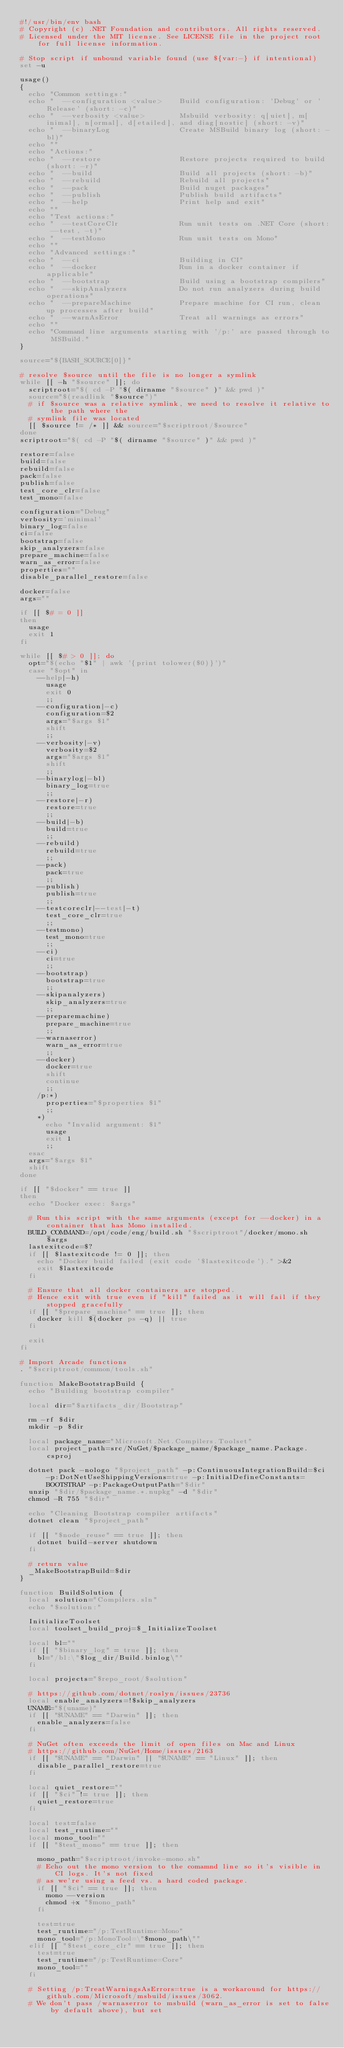Convert code to text. <code><loc_0><loc_0><loc_500><loc_500><_Bash_>#!/usr/bin/env bash
# Copyright (c) .NET Foundation and contributors. All rights reserved.
# Licensed under the MIT license. See LICENSE file in the project root for full license information.

# Stop script if unbound variable found (use ${var:-} if intentional)
set -u

usage()
{
  echo "Common settings:"
  echo "  --configuration <value>    Build configuration: 'Debug' or 'Release' (short: -c)"
  echo "  --verbosity <value>        Msbuild verbosity: q[uiet], m[inimal], n[ormal], d[etailed], and diag[nostic] (short: -v)"
  echo "  --binaryLog                Create MSBuild binary log (short: -bl)"
  echo ""
  echo "Actions:"
  echo "  --restore                  Restore projects required to build (short: -r)"
  echo "  --build                    Build all projects (short: -b)"
  echo "  --rebuild                  Rebuild all projects"
  echo "  --pack                     Build nuget packages"
  echo "  --publish                  Publish build artifacts"
  echo "  --help                     Print help and exit"
  echo ""
  echo "Test actions:"     
  echo "  --testCoreClr              Run unit tests on .NET Core (short: --test, -t)"
  echo "  --testMono                 Run unit tests on Mono"
  echo ""
  echo "Advanced settings:"
  echo "  --ci                       Building in CI"
  echo "  --docker                   Run in a docker container if applicable"
  echo "  --bootstrap                Build using a bootstrap compilers"
  echo "  --skipAnalyzers            Do not run analyzers during build operations"
  echo "  --prepareMachine           Prepare machine for CI run, clean up processes after build"
  echo "  --warnAsError              Treat all warnings as errors"
  echo ""
  echo "Command line arguments starting with '/p:' are passed through to MSBuild."
}

source="${BASH_SOURCE[0]}"

# resolve $source until the file is no longer a symlink
while [[ -h "$source" ]]; do
  scriptroot="$( cd -P "$( dirname "$source" )" && pwd )"
  source="$(readlink "$source")"
  # if $source was a relative symlink, we need to resolve it relative to the path where the
  # symlink file was located
  [[ $source != /* ]] && source="$scriptroot/$source"
done
scriptroot="$( cd -P "$( dirname "$source" )" && pwd )"

restore=false
build=false
rebuild=false
pack=false
publish=false
test_core_clr=false
test_mono=false

configuration="Debug"
verbosity='minimal'
binary_log=false
ci=false
bootstrap=false
skip_analyzers=false
prepare_machine=false
warn_as_error=false
properties=""
disable_parallel_restore=false

docker=false
args=""

if [[ $# = 0 ]]
then
  usage
  exit 1
fi

while [[ $# > 0 ]]; do
  opt="$(echo "$1" | awk '{print tolower($0)}')"
  case "$opt" in
    --help|-h)
      usage
      exit 0
      ;;
    --configuration|-c)
      configuration=$2
      args="$args $1"
      shift
      ;;
    --verbosity|-v)
      verbosity=$2
      args="$args $1"
      shift
      ;;
    --binarylog|-bl)
      binary_log=true
      ;;
    --restore|-r)
      restore=true
      ;;
    --build|-b)
      build=true
      ;;
    --rebuild)
      rebuild=true
      ;;
    --pack)
      pack=true
      ;;
    --publish)
      publish=true
      ;;
    --testcoreclr|--test|-t)
      test_core_clr=true
      ;;
    --testmono)
      test_mono=true
      ;;
    --ci)
      ci=true
      ;;
    --bootstrap)
      bootstrap=true
      ;;
    --skipanalyzers)
      skip_analyzers=true
      ;;
    --preparemachine)
      prepare_machine=true
      ;;
    --warnaserror)
      warn_as_error=true
      ;;
    --docker)
      docker=true
      shift
      continue
      ;;
    /p:*)
      properties="$properties $1"
      ;;
    *)
      echo "Invalid argument: $1"
      usage
      exit 1
      ;;
  esac
  args="$args $1"
  shift
done

if [[ "$docker" == true ]]
then
  echo "Docker exec: $args"

  # Run this script with the same arguments (except for --docker) in a container that has Mono installed.
  BUILD_COMMAND=/opt/code/eng/build.sh "$scriptroot"/docker/mono.sh $args
  lastexitcode=$?
  if [[ $lastexitcode != 0 ]]; then
    echo "Docker build failed (exit code '$lastexitcode')." >&2
    exit $lastexitcode
  fi

  # Ensure that all docker containers are stopped.
  # Hence exit with true even if "kill" failed as it will fail if they stopped gracefully
  if [[ "$prepare_machine" == true ]]; then
    docker kill $(docker ps -q) || true
  fi

  exit
fi

# Import Arcade functions
. "$scriptroot/common/tools.sh"

function MakeBootstrapBuild {
  echo "Building bootstrap compiler"

  local dir="$artifacts_dir/Bootstrap"

  rm -rf $dir
  mkdir -p $dir

  local package_name="Microsoft.Net.Compilers.Toolset"
  local project_path=src/NuGet/$package_name/$package_name.Package.csproj

  dotnet pack -nologo "$project_path" -p:ContinuousIntegrationBuild=$ci -p:DotNetUseShippingVersions=true -p:InitialDefineConstants=BOOTSTRAP -p:PackageOutputPath="$dir"
  unzip "$dir/$package_name.*.nupkg" -d "$dir"
  chmod -R 755 "$dir"

  echo "Cleaning Bootstrap compiler artifacts"
  dotnet clean "$project_path"

  if [[ "$node_reuse" == true ]]; then
    dotnet build-server shutdown
  fi

  # return value
  _MakeBootstrapBuild=$dir
}

function BuildSolution {
  local solution="Compilers.sln"
  echo "$solution:"

  InitializeToolset
  local toolset_build_proj=$_InitializeToolset
  
  local bl=""
  if [[ "$binary_log" = true ]]; then
    bl="/bl:\"$log_dir/Build.binlog\""
  fi
  
  local projects="$repo_root/$solution" 
  
  # https://github.com/dotnet/roslyn/issues/23736
  local enable_analyzers=!$skip_analyzers
  UNAME="$(uname)"
  if [[ "$UNAME" == "Darwin" ]]; then
    enable_analyzers=false
  fi

  # NuGet often exceeds the limit of open files on Mac and Linux
  # https://github.com/NuGet/Home/issues/2163
  if [[ "$UNAME" == "Darwin" || "$UNAME" == "Linux" ]]; then
    disable_parallel_restore=true
  fi

  local quiet_restore=""
  if [[ "$ci" != true ]]; then
    quiet_restore=true
  fi

  local test=false
  local test_runtime=""
  local mono_tool=""
  if [[ "$test_mono" == true ]]; then
    
    mono_path="$scriptroot/invoke-mono.sh"
    # Echo out the mono version to the comamnd line so it's visible in CI logs. It's not fixed
    # as we're using a feed vs. a hard coded package.
    if [[ "$ci" == true ]]; then
      mono --version
      chmod +x "$mono_path"
    fi

    test=true
    test_runtime="/p:TestRuntime=Mono"
    mono_tool="/p:MonoTool=\"$mono_path\""
  elif [[ "$test_core_clr" == true ]]; then
    test=true
    test_runtime="/p:TestRuntime=Core"
    mono_tool=""
  fi

  # Setting /p:TreatWarningsAsErrors=true is a workaround for https://github.com/Microsoft/msbuild/issues/3062.
  # We don't pass /warnaserror to msbuild (warn_as_error is set to false by default above), but set </code> 